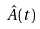<formula> <loc_0><loc_0><loc_500><loc_500>\hat { A } ( t )</formula> 